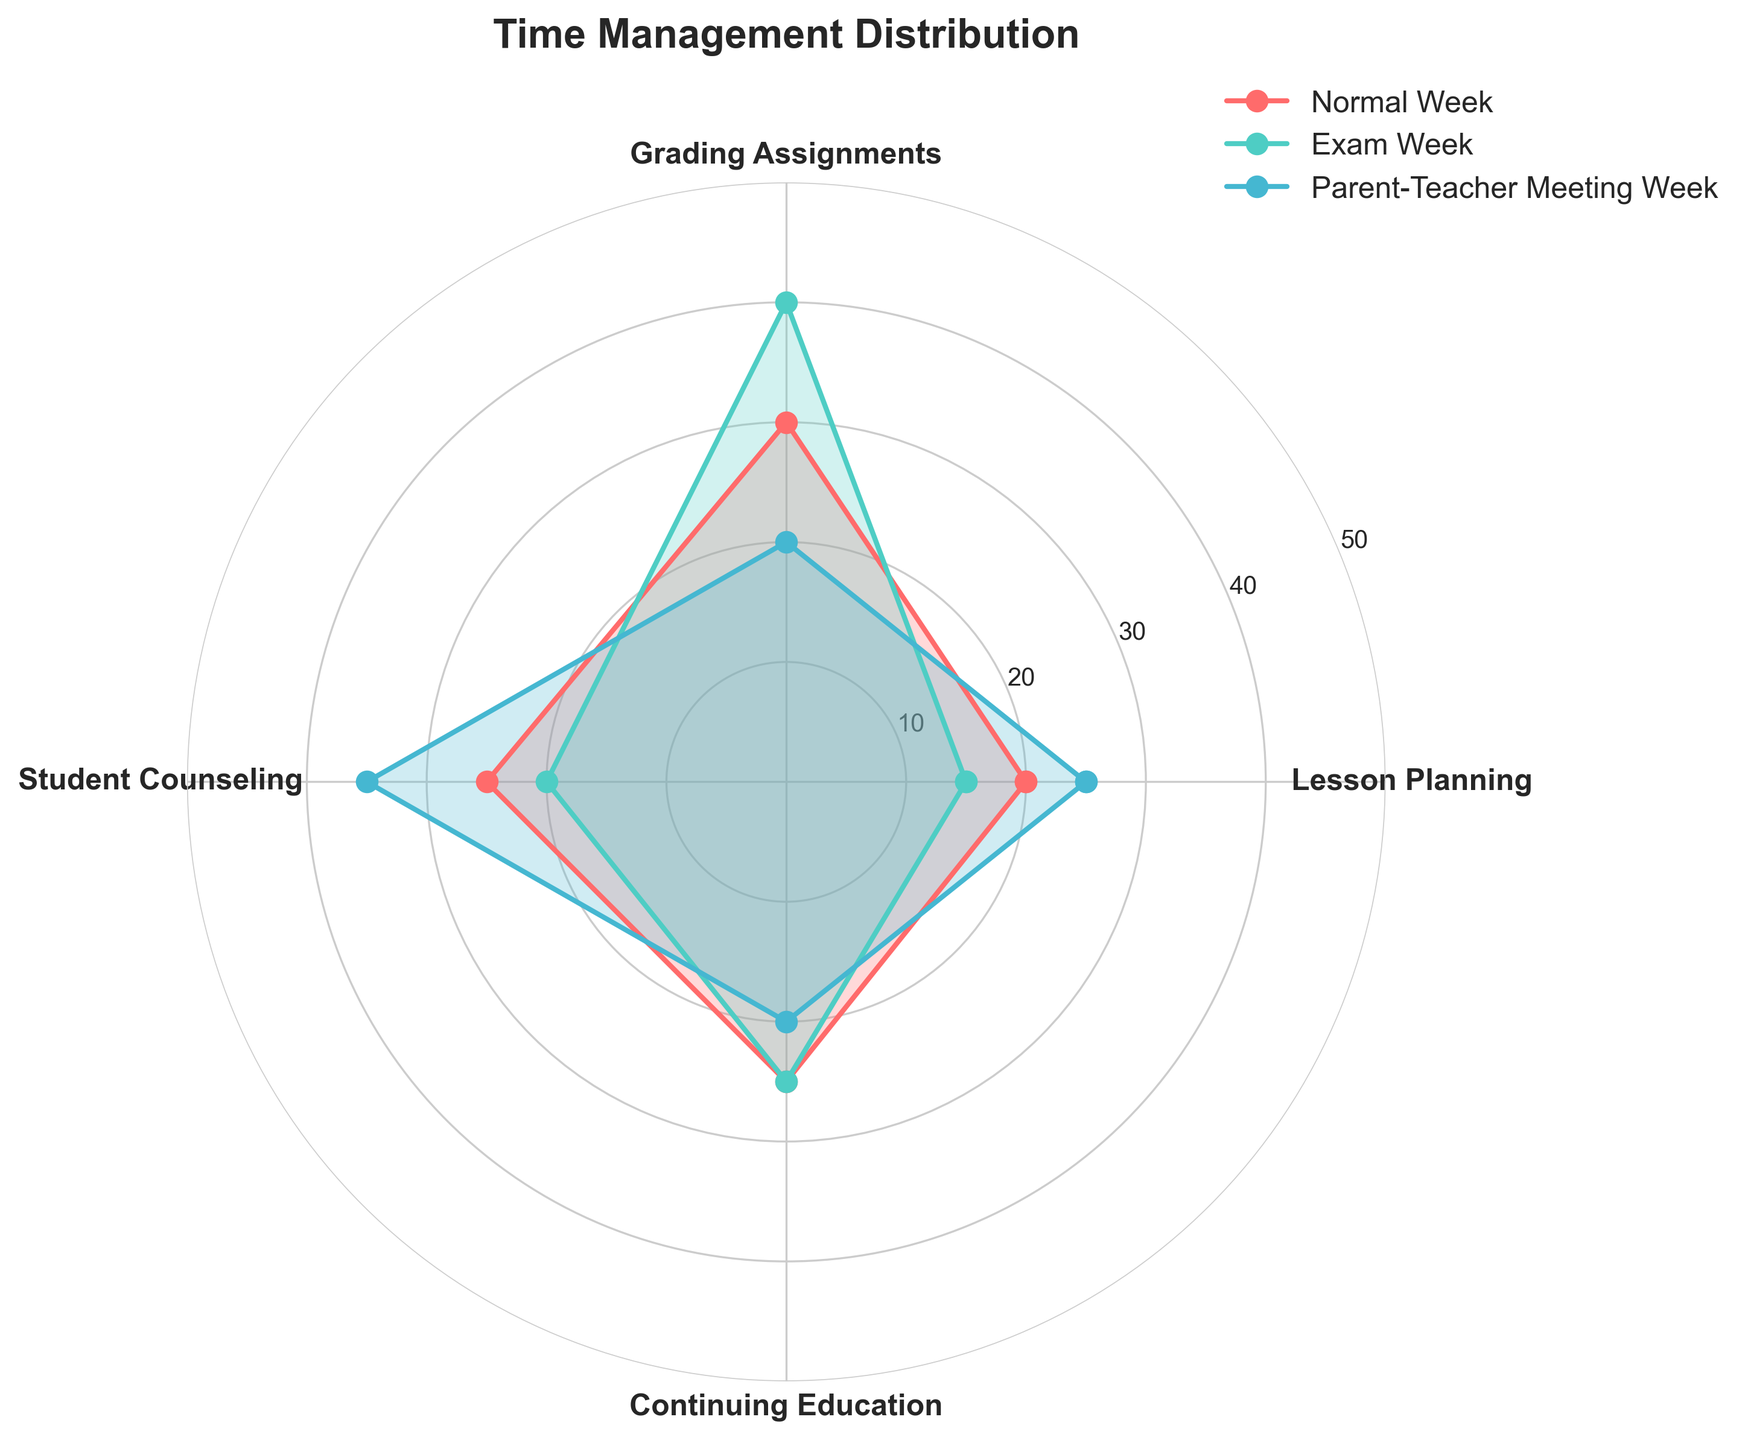What's the highest percentage of time spent on Lesson Planning in any week? By observing the radar chart, the maximum point for Lesson Planning occurs during the Parent-Teacher Meeting Week, where the value is 25%.
Answer: 25% In which week is the time spent on Grading Assignments the highest? Looking at the data points for Grading Assignments in the radar chart, the highest value is during Exam Week with a percentage of 40%.
Answer: Exam Week How many different colors are used to represent the weeks? There are three distinct colors representing the three different weeks. This can be seen from the legend and the colored lines and filled areas in the radar chart.
Answer: Three What is the combined percentage of time spent on Student Counseling during Normal Week and Exam Week? Adding the data points of Student Counseling from Normal Week (25%) and Exam Week (20%) results in a total of 45%.
Answer: 45% Which activity shows the biggest difference in time allocation between Normal Week and Exam Week? The difference in Lesson Planning is 5% (20-15), the difference in Grading Assignments is 10% (30-40), the difference in Student Counseling is 5% (25-20), and the difference in Continuing Education is 0% (25-25). The biggest difference is in Grading Assignments with 10%.
Answer: Grading Assignments Is the percentage of time spent on Continuing Education ever the same across any two weeks? Observing the radar chart, the Continuing Education value remains at 25% for both Normal Week and Exam Week, showing consistency.
Answer: Yes Which activity has the most balanced distribution of time across all three weeks? Examining the radar chart, Continuing Education remains relatively consistent, with values at 25% for Normal Week and Exam Week, and 20% for Parent-Teacher Meeting Week.
Answer: Continuing Education Does any activity exceed 35% of time allocation in any week? By analyzing the radar chart, we see that Grading Assignments during Exam Week reaches 40%, which exceeds 35%. No other activity exceeds 35% in any week.
Answer: Yes, Grading Assignments during Exam Week What is the average percentage of time spent on Lesson Planning over the three weeks? Adding the percentages of Lesson Planning for each week: 20% (Normal Week), 15% (Exam Week), and 25% (Parent-Teacher Meeting Week) gives a total of 60%. Dividing by 3, the average is 60/3 = 20%.
Answer: 20% In which week is the least amount of time spent on Student Counseling? Checking the radar chart, the least time spent on Student Counseling is during Exam Week with 20%.
Answer: Exam Week 